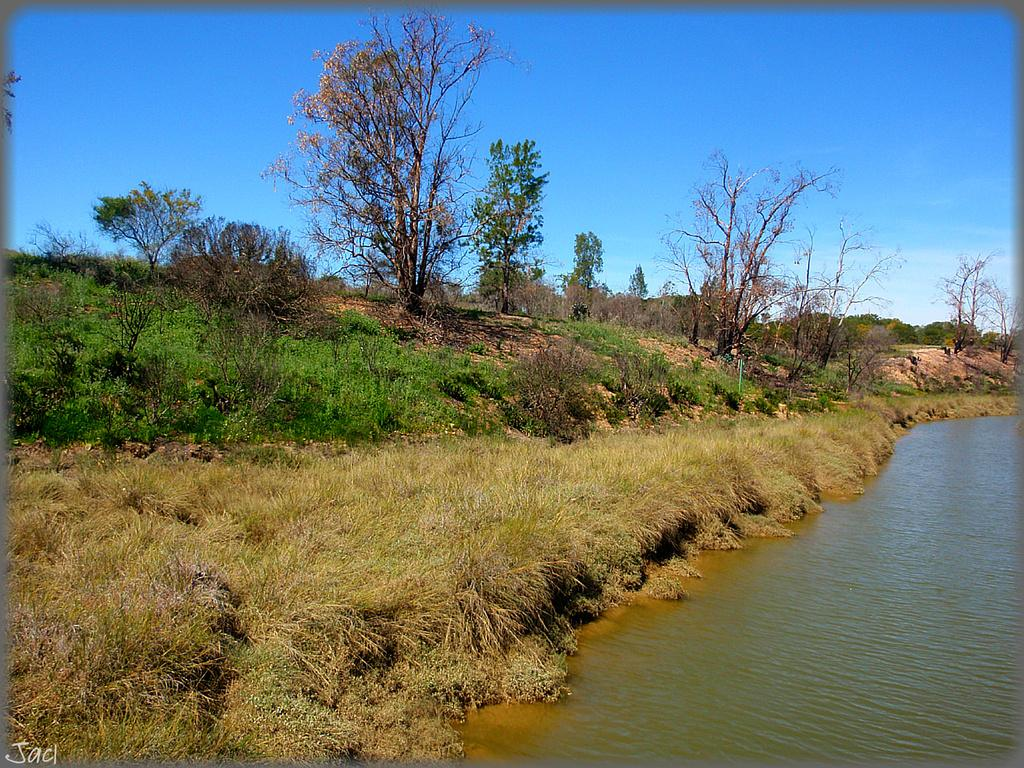What type of vegetation is present in the image? There are trees in the image. What is the ground covered with in the image? There is grass on the ground in the image. What natural element can be seen in the image besides trees and grass? There is water visible in the image. How would you describe the sky in the image? The sky is blue and cloudy in the image. What type of vacation is being enjoyed by the people in the image? There are no people visible in the image, so it is impossible to determine if they are on vacation or not. 